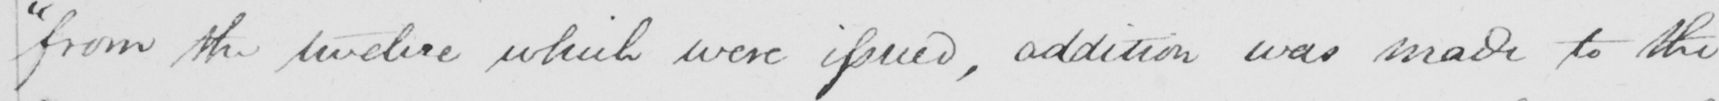Transcribe the text shown in this historical manuscript line. " from the twelve which were issued , addition was made to the 